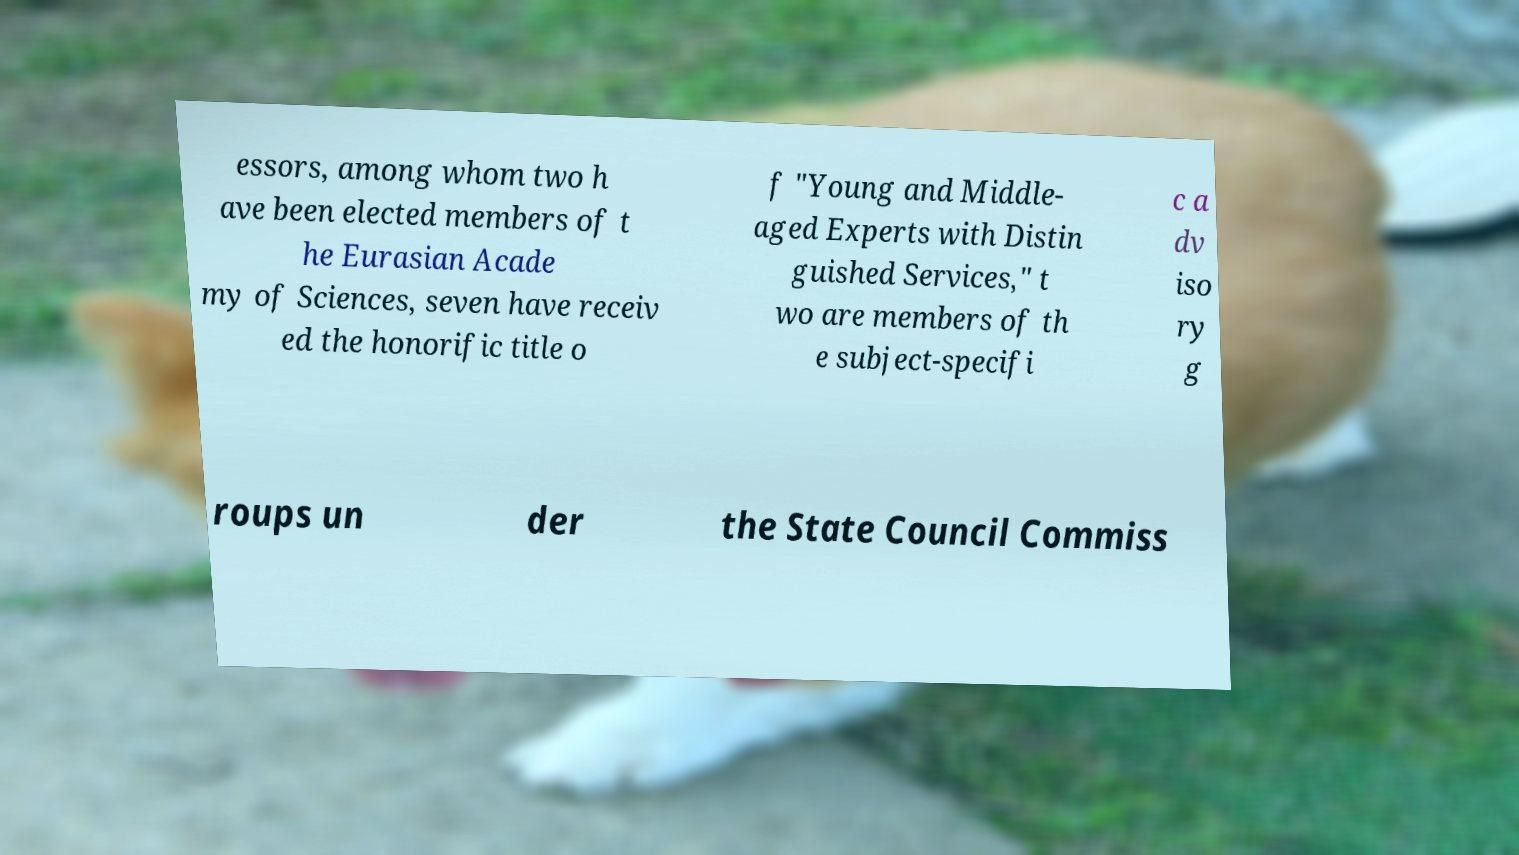I need the written content from this picture converted into text. Can you do that? essors, among whom two h ave been elected members of t he Eurasian Acade my of Sciences, seven have receiv ed the honorific title o f "Young and Middle- aged Experts with Distin guished Services," t wo are members of th e subject-specifi c a dv iso ry g roups un der the State Council Commiss 